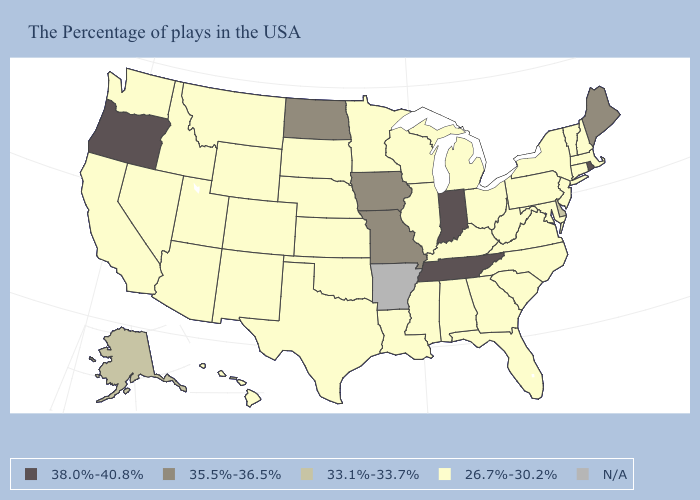What is the highest value in the West ?
Short answer required. 38.0%-40.8%. Does Tennessee have the highest value in the South?
Quick response, please. Yes. What is the value of Nebraska?
Write a very short answer. 26.7%-30.2%. Name the states that have a value in the range 26.7%-30.2%?
Keep it brief. Massachusetts, New Hampshire, Vermont, Connecticut, New York, New Jersey, Maryland, Pennsylvania, Virginia, North Carolina, South Carolina, West Virginia, Ohio, Florida, Georgia, Michigan, Kentucky, Alabama, Wisconsin, Illinois, Mississippi, Louisiana, Minnesota, Kansas, Nebraska, Oklahoma, Texas, South Dakota, Wyoming, Colorado, New Mexico, Utah, Montana, Arizona, Idaho, Nevada, California, Washington, Hawaii. Does New York have the lowest value in the USA?
Short answer required. Yes. Is the legend a continuous bar?
Quick response, please. No. How many symbols are there in the legend?
Short answer required. 5. What is the highest value in states that border Illinois?
Short answer required. 38.0%-40.8%. What is the lowest value in states that border Illinois?
Give a very brief answer. 26.7%-30.2%. Name the states that have a value in the range N/A?
Quick response, please. Arkansas. What is the value of California?
Keep it brief. 26.7%-30.2%. Name the states that have a value in the range 38.0%-40.8%?
Keep it brief. Rhode Island, Indiana, Tennessee, Oregon. What is the lowest value in the USA?
Short answer required. 26.7%-30.2%. 